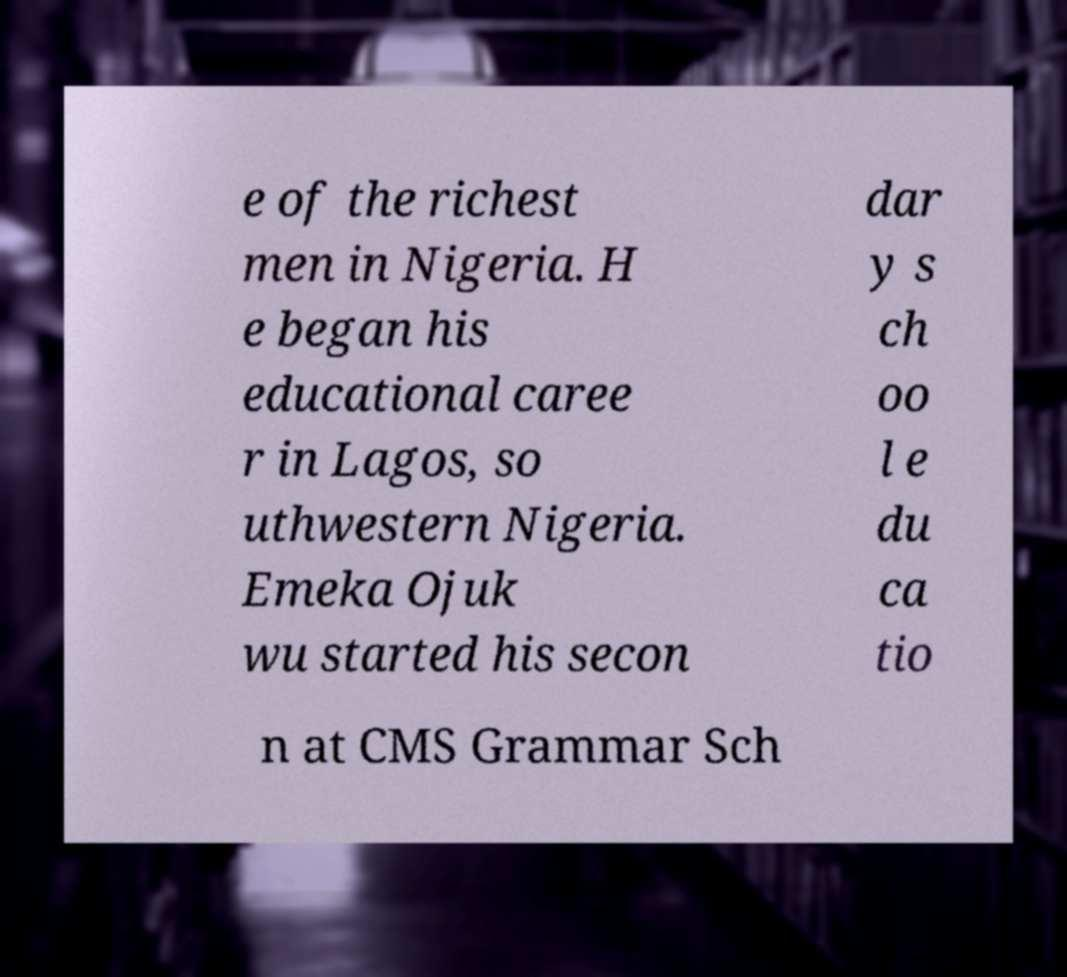There's text embedded in this image that I need extracted. Can you transcribe it verbatim? e of the richest men in Nigeria. H e began his educational caree r in Lagos, so uthwestern Nigeria. Emeka Ojuk wu started his secon dar y s ch oo l e du ca tio n at CMS Grammar Sch 